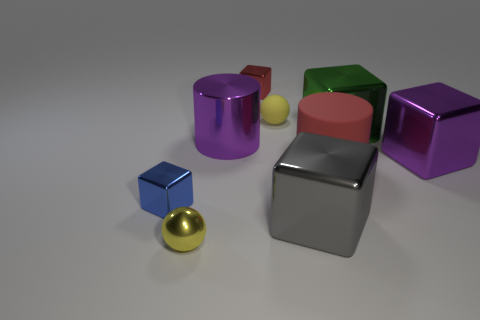Is the color of the shiny ball the same as the rubber thing behind the purple metal cube?
Offer a very short reply. Yes. Is there anything else that is the same color as the matte ball?
Provide a short and direct response. Yes. What is the object that is to the right of the red block and left of the gray shiny cube made of?
Make the answer very short. Rubber. What number of other large objects are the same shape as the green metal object?
Offer a terse response. 2. There is a big cube to the left of the big green block that is to the right of the blue metal thing; what is its color?
Offer a terse response. Gray. Are there an equal number of big metallic cubes in front of the small blue object and green shiny objects?
Offer a terse response. Yes. Are there any red cylinders that have the same size as the gray shiny thing?
Your answer should be very brief. Yes. There is a red rubber cylinder; is it the same size as the cube to the right of the green shiny block?
Ensure brevity in your answer.  Yes. Are there the same number of tiny metal blocks behind the big red matte cylinder and green cubes that are behind the rubber sphere?
Make the answer very short. No. There is another thing that is the same color as the large rubber thing; what is its shape?
Your answer should be compact. Cube. 